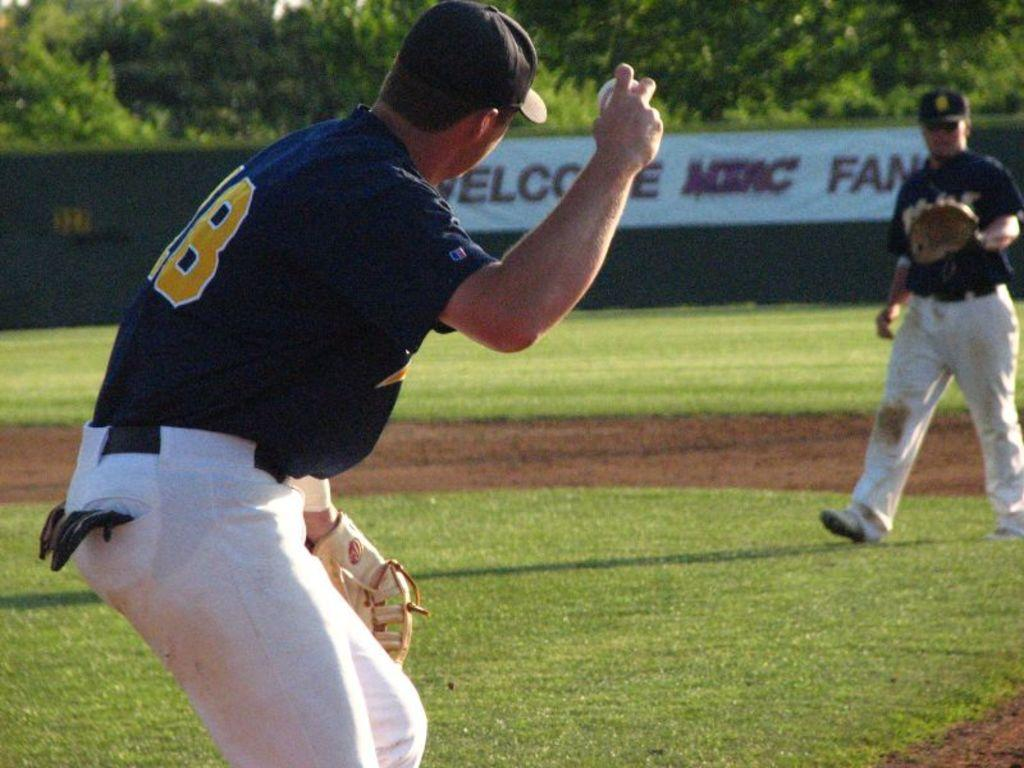Provide a one-sentence caption for the provided image. The person in the 18 jersey is getting ready to throw the ball to the other player. 